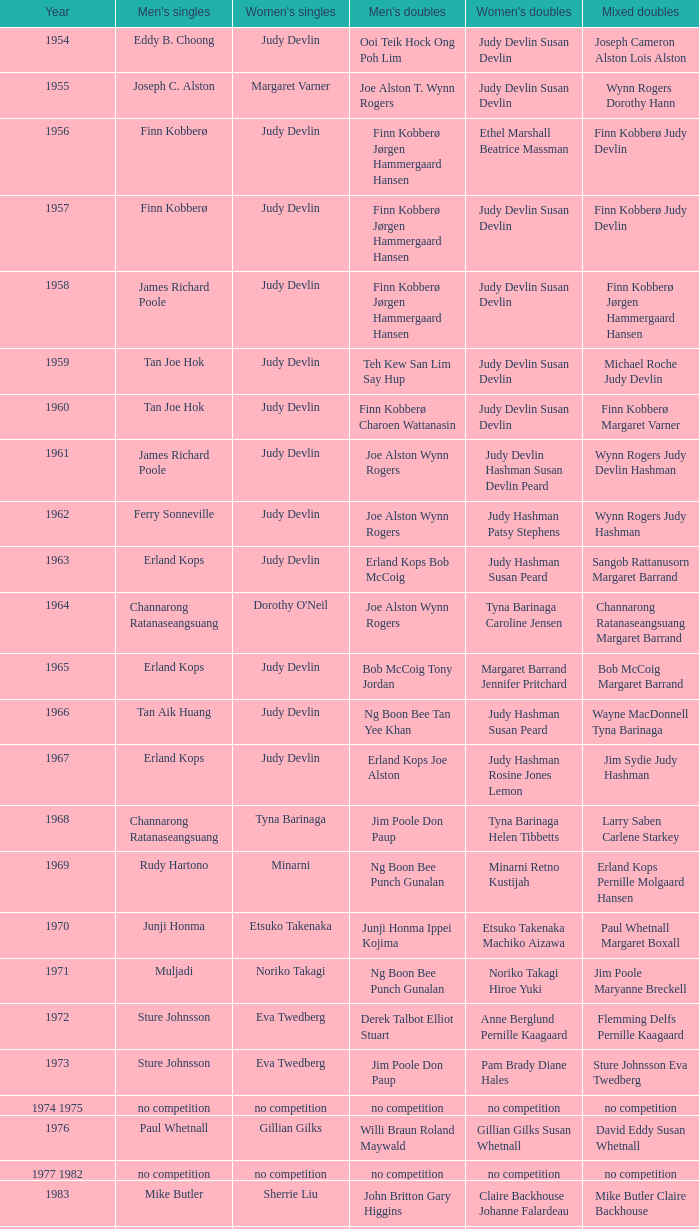Who were the men's doubles triumphant duo when the men's singles conqueror was muljadi? Ng Boon Bee Punch Gunalan. 